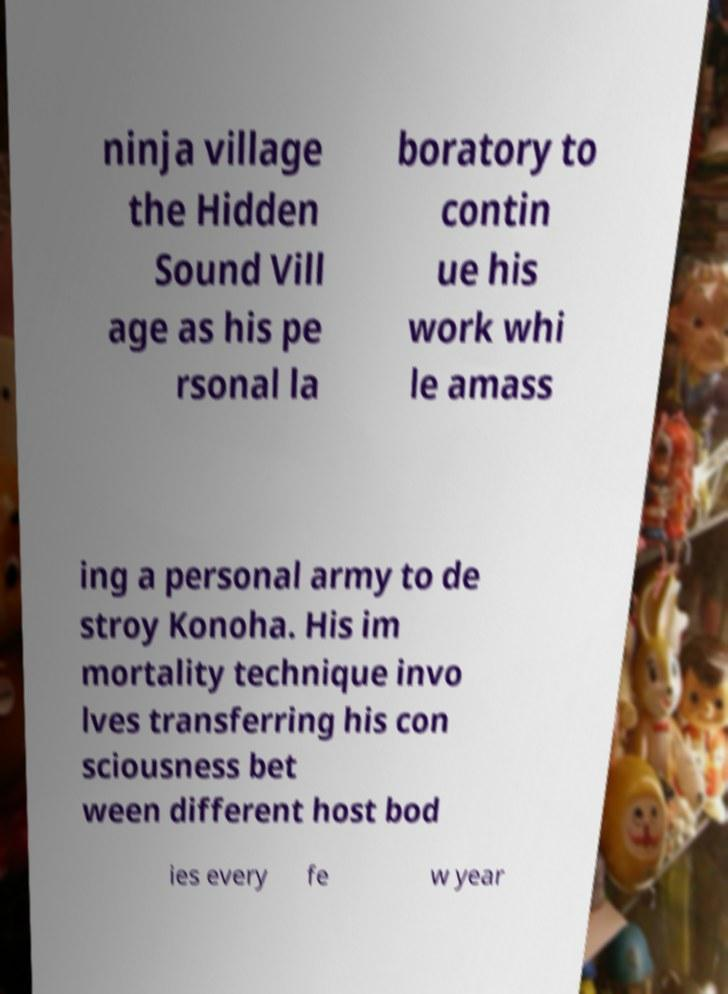Could you assist in decoding the text presented in this image and type it out clearly? ninja village the Hidden Sound Vill age as his pe rsonal la boratory to contin ue his work whi le amass ing a personal army to de stroy Konoha. His im mortality technique invo lves transferring his con sciousness bet ween different host bod ies every fe w year 